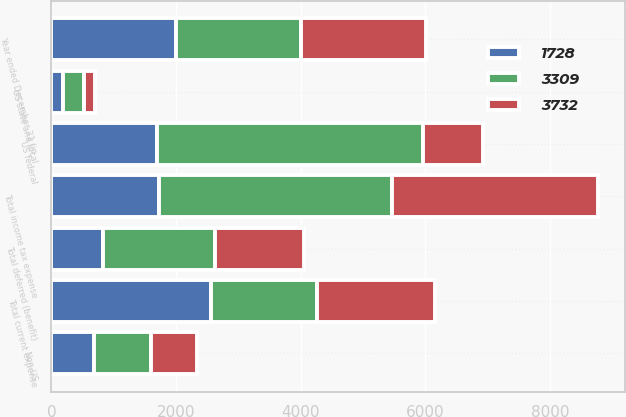Convert chart. <chart><loc_0><loc_0><loc_500><loc_500><stacked_bar_chart><ecel><fcel>Year ended December 31 (in<fcel>US federal<fcel>Non-US<fcel>US state and local<fcel>Total current expense<fcel>Total deferred (benefit)<fcel>Total income tax expense<nl><fcel>3309<fcel>2005<fcel>4269<fcel>917<fcel>337<fcel>1711.5<fcel>1791<fcel>3732<nl><fcel>1728<fcel>2004<fcel>1695<fcel>679<fcel>181<fcel>2555<fcel>827<fcel>1728<nl><fcel>3732<fcel>2003<fcel>965<fcel>741<fcel>175<fcel>1881<fcel>1428<fcel>3309<nl></chart> 